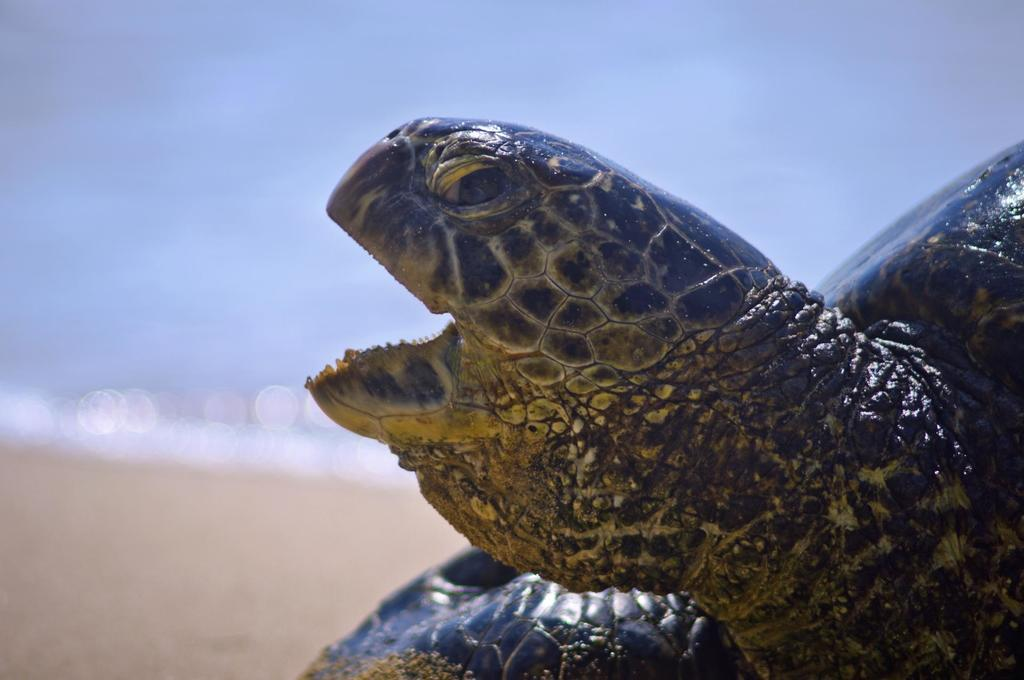What type of animal is in the image? There is a tortoise in the image. What type of terrain is visible in the image? There is sand in the image. What color is the background of the image? The background of the image is white. What type of hose is being used by the authority in the image? There is no hose or authority present in the image; it only features a tortoise and sand on a white background. 